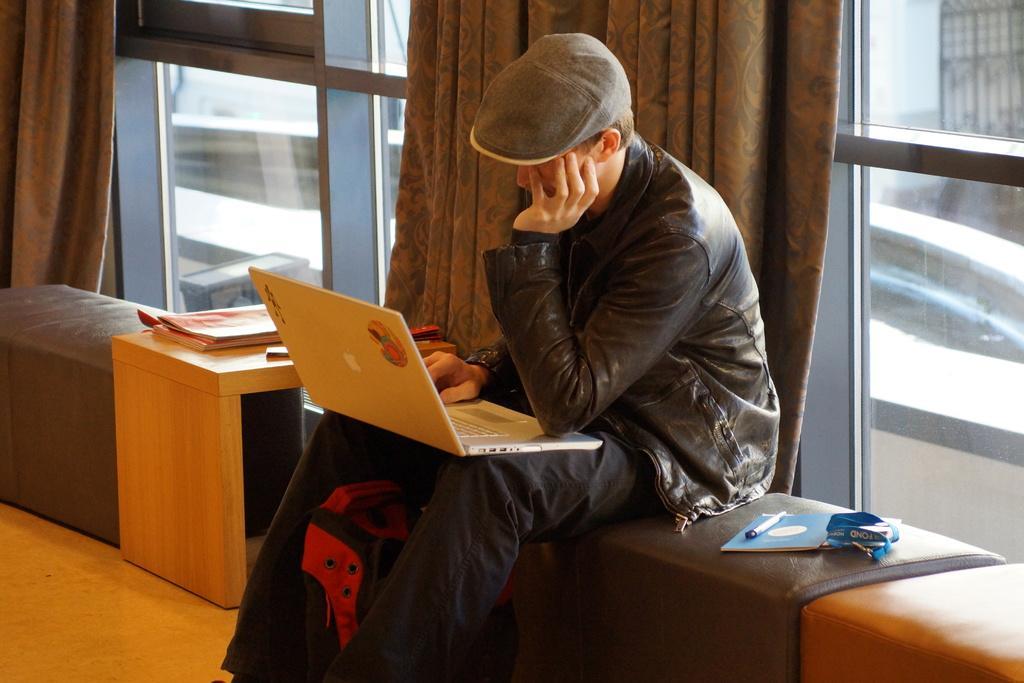Could you give a brief overview of what you see in this image? This picture is clicked inside. In the center there is a person wearing a black color jacket, working on a laptop and sitting on a couch and we can see a book and some other items are placed on the couch. On the left there are some items placed on the top of the wooden table. In the background we can see the windows and the curtains and through the windows we can see the outside view. 